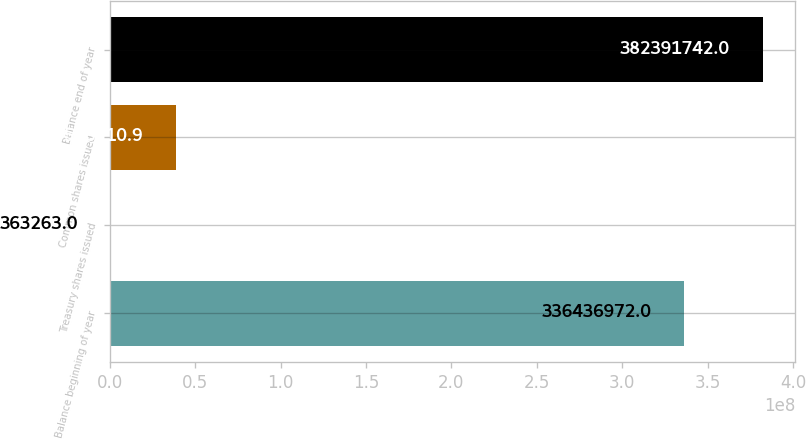<chart> <loc_0><loc_0><loc_500><loc_500><bar_chart><fcel>Balance beginning of year<fcel>Treasury shares issued<fcel>Common shares issued<fcel>Balance end of year<nl><fcel>3.36437e+08<fcel>363263<fcel>3.85661e+07<fcel>3.82392e+08<nl></chart> 